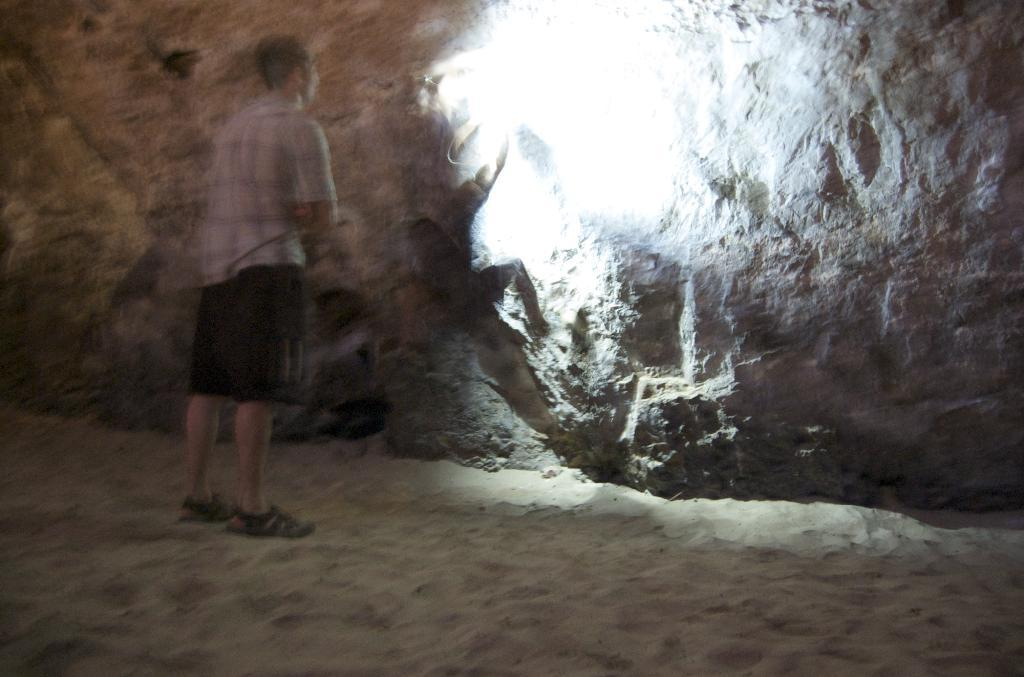Who or what can be seen in the image? There are people in the image. What is visible in the background of the image? There is a wall in the background of the image. What type of clouds can be seen in the image? There are no clouds visible in the image, as it features people and a wall in the background. Is there any liquid present in the image? There is no liquid visible in the image. Can you see any chickens in the image? There are no chickens present in the image. 